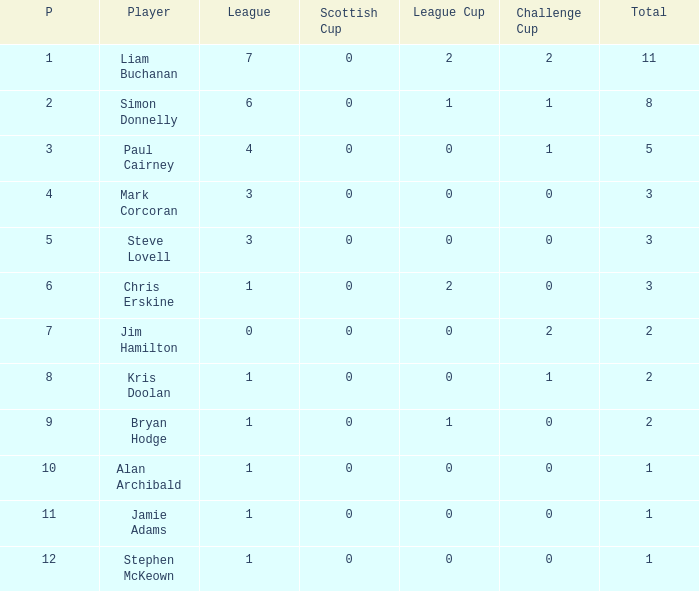Can you tell me kris doolan's league number? 1.0. 